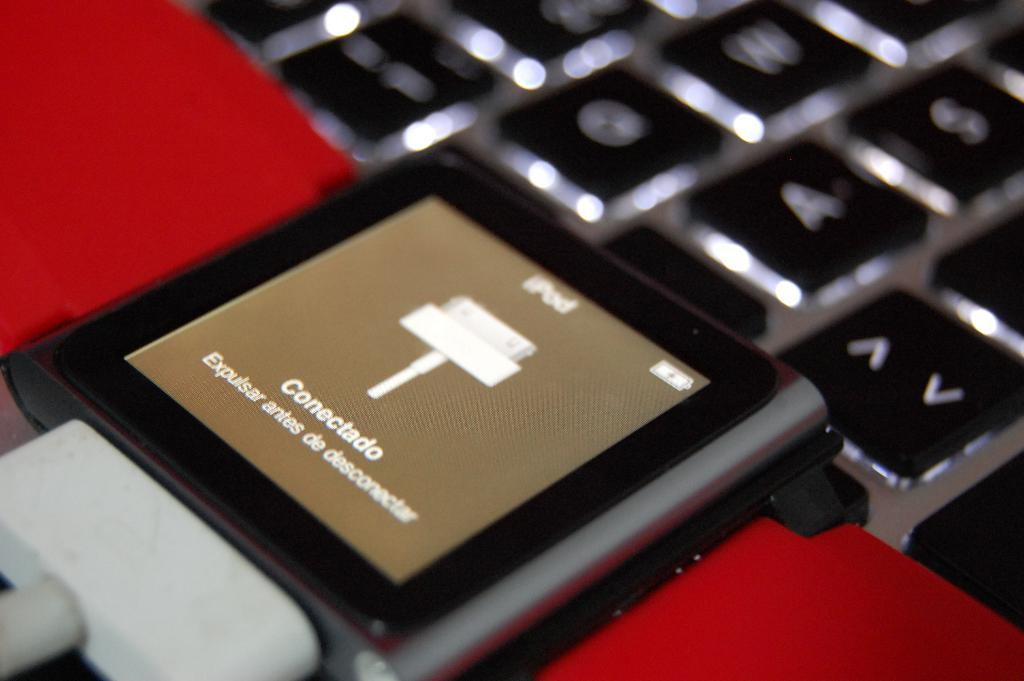Provide a one-sentence caption for the provided image. The iPod screen reads "Conectado" over a brown background. 